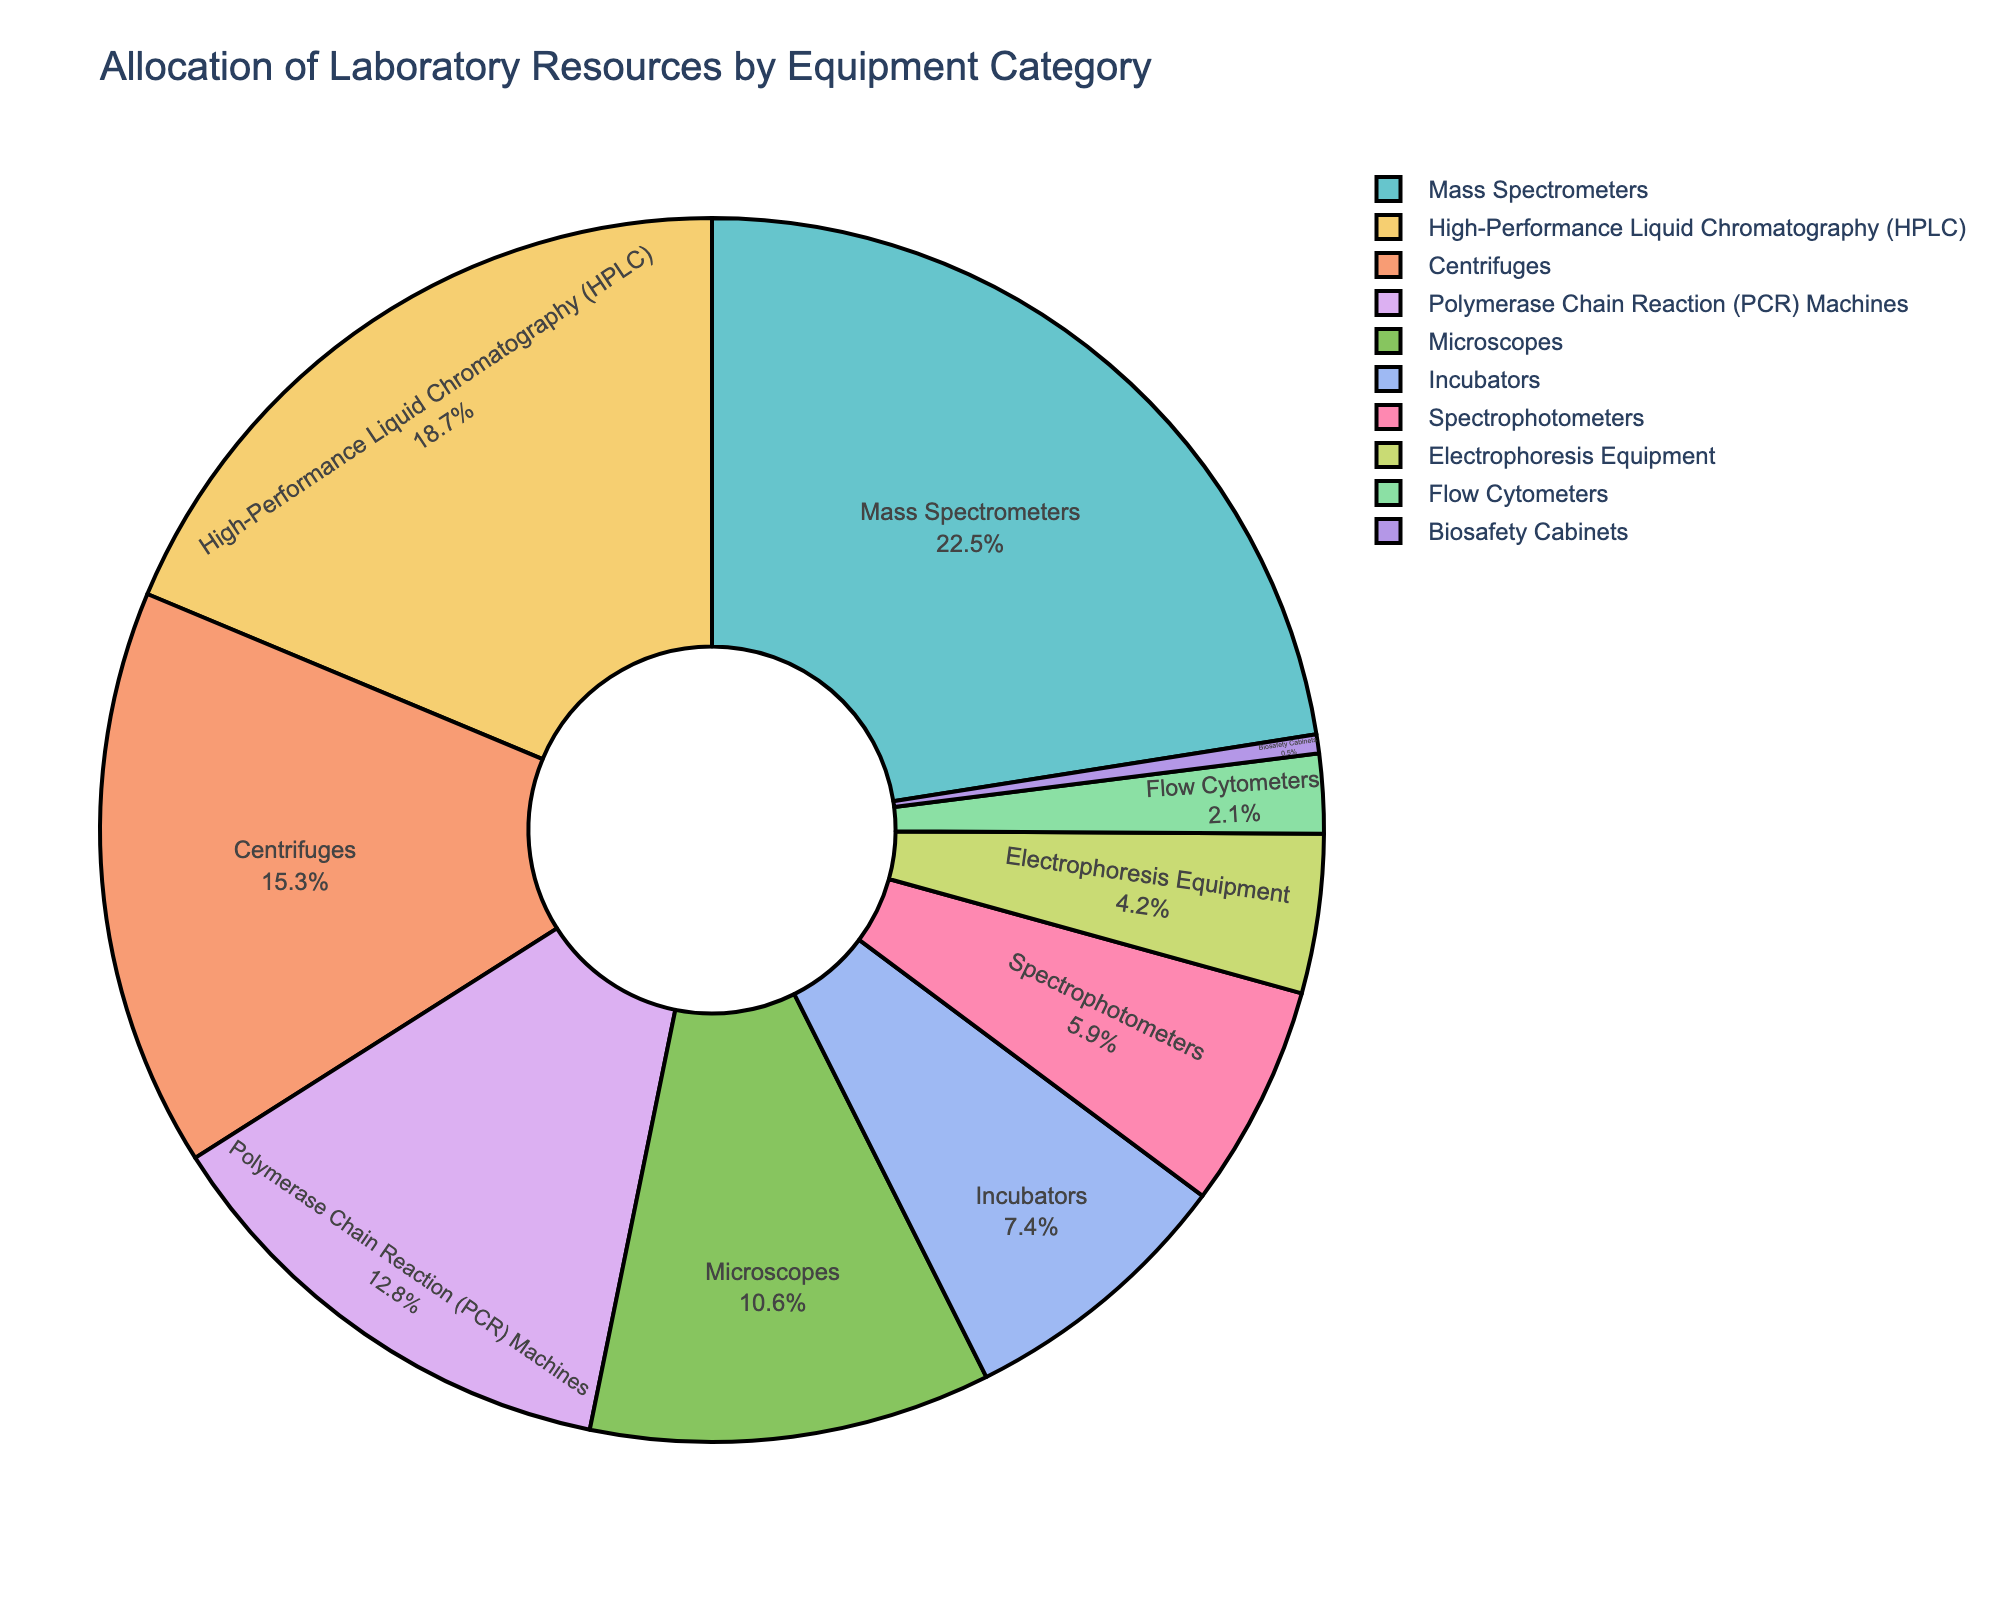Which equipment category has the largest allocation percentage? Look at the segment with the highest percentage value. Mass Spectrometers have the largest slice, labeled as 22.5%.
Answer: Mass Spectrometers What is the combined allocation percentage of HPLC and PCR Machines? Sum the percentages of HPLC (18.7%) and PCR Machines (12.8%). 18.7% + 12.8% = 31.5%.
Answer: 31.5% How much more percentage is allocated to Microscopes compared to Flow Cytometers? Subtract the percentage of Flow Cytometers (2.1%) from Microscopes (10.6%). 10.6% - 2.1% = 8.5%.
Answer: 8.5% Which has a smaller allocation, Spectrophotometers or Centrifuges? Compare the percentages of Spectrophotometers (5.9%) and Centrifuges (15.3%). Spectrophotometers have a smaller allocation.
Answer: Spectrophotometers Does any category have an allocation percentage less than 1%? Identify segments with percentages less than 1%. Biosafety Cabinets have 0.5%.
Answer: Yes What is the cumulative allocation percentage of the three least allocated equipment categories? Add the percentages of Flow Cytometers (2.1%), Electrophoresis Equipment (4.2%), and Biosafety Cabinets (0.5%). 2.1% + 4.2% + 0.5% = 6.8%.
Answer: 6.8% Which equipment category has the closest allocation percentage to the average allocation of all categories? First, calculate the average allocation by summing all percentages (22.5 + 18.7 + 15.3 + 12.8 + 10.6 + 7.4 + 5.9 + 4.2 + 2.1 + 0.5 = 100) and dividing by the number of categories (10). The average is 10%. Microscopes (10.6%) is closest to this average.
Answer: Microscopes By how much does the allocation percentage for HPLC exceed the sum of the allocations for Incubators and Electrophoresis Equipment? First, calculate the sum of Incubators (7.4%) and Electrophoresis Equipment (4.2%). 7.4% + 4.2% = 11.6%. Then, subtract this sum from HPLC (18.7%). 18.7% - 11.6% = 7.1%.
Answer: 7.1% 